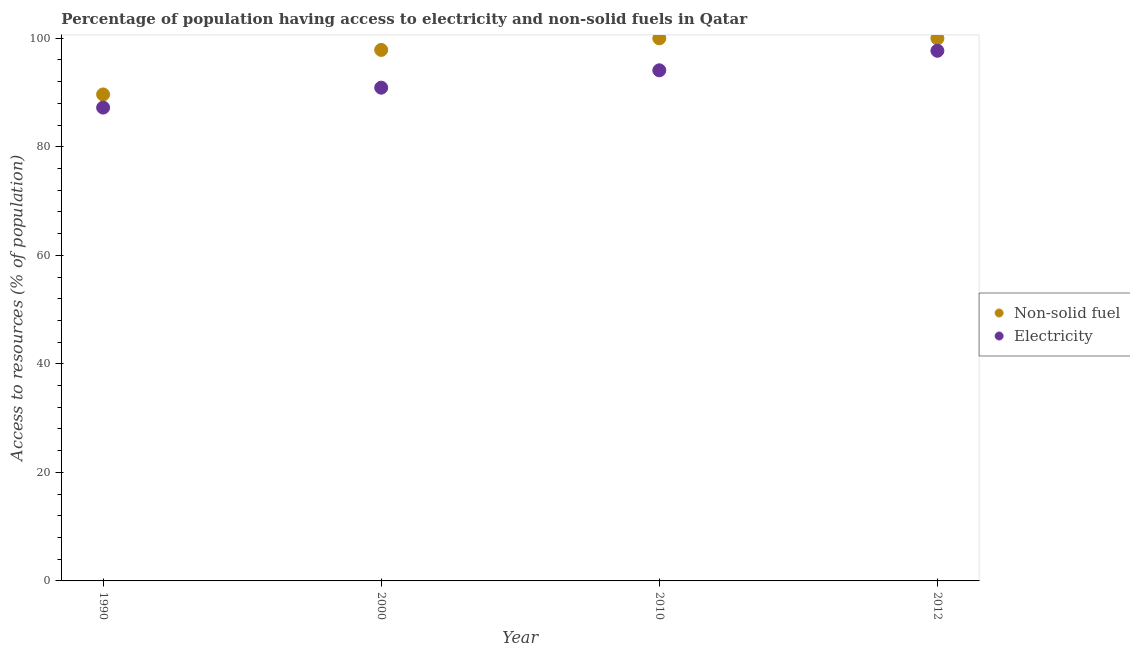What is the percentage of population having access to electricity in 1990?
Offer a terse response. 87.23. Across all years, what is the maximum percentage of population having access to non-solid fuel?
Provide a short and direct response. 99.99. Across all years, what is the minimum percentage of population having access to non-solid fuel?
Provide a short and direct response. 89.65. What is the total percentage of population having access to non-solid fuel in the graph?
Ensure brevity in your answer.  387.49. What is the difference between the percentage of population having access to non-solid fuel in 1990 and that in 2012?
Your response must be concise. -10.34. What is the difference between the percentage of population having access to non-solid fuel in 2012 and the percentage of population having access to electricity in 1990?
Provide a succinct answer. 12.76. What is the average percentage of population having access to electricity per year?
Provide a short and direct response. 92.48. In the year 2012, what is the difference between the percentage of population having access to electricity and percentage of population having access to non-solid fuel?
Make the answer very short. -2.29. In how many years, is the percentage of population having access to non-solid fuel greater than 64 %?
Offer a terse response. 4. What is the ratio of the percentage of population having access to non-solid fuel in 2010 to that in 2012?
Your response must be concise. 1. What is the difference between the highest and the lowest percentage of population having access to electricity?
Provide a short and direct response. 10.47. Is the sum of the percentage of population having access to non-solid fuel in 2000 and 2010 greater than the maximum percentage of population having access to electricity across all years?
Give a very brief answer. Yes. Does the percentage of population having access to electricity monotonically increase over the years?
Give a very brief answer. Yes. Is the percentage of population having access to electricity strictly less than the percentage of population having access to non-solid fuel over the years?
Ensure brevity in your answer.  Yes. How many dotlines are there?
Offer a terse response. 2. What is the difference between two consecutive major ticks on the Y-axis?
Your response must be concise. 20. Where does the legend appear in the graph?
Offer a very short reply. Center right. What is the title of the graph?
Ensure brevity in your answer.  Percentage of population having access to electricity and non-solid fuels in Qatar. What is the label or title of the Y-axis?
Provide a succinct answer. Access to resources (% of population). What is the Access to resources (% of population) in Non-solid fuel in 1990?
Your response must be concise. 89.65. What is the Access to resources (% of population) of Electricity in 1990?
Your answer should be very brief. 87.23. What is the Access to resources (% of population) in Non-solid fuel in 2000?
Make the answer very short. 97.86. What is the Access to resources (% of population) of Electricity in 2000?
Your response must be concise. 90.9. What is the Access to resources (% of population) of Non-solid fuel in 2010?
Provide a succinct answer. 99.99. What is the Access to resources (% of population) in Electricity in 2010?
Offer a terse response. 94.1. What is the Access to resources (% of population) in Non-solid fuel in 2012?
Your answer should be very brief. 99.99. What is the Access to resources (% of population) of Electricity in 2012?
Keep it short and to the point. 97.7. Across all years, what is the maximum Access to resources (% of population) in Non-solid fuel?
Offer a very short reply. 99.99. Across all years, what is the maximum Access to resources (% of population) in Electricity?
Provide a short and direct response. 97.7. Across all years, what is the minimum Access to resources (% of population) in Non-solid fuel?
Make the answer very short. 89.65. Across all years, what is the minimum Access to resources (% of population) in Electricity?
Ensure brevity in your answer.  87.23. What is the total Access to resources (% of population) in Non-solid fuel in the graph?
Provide a succinct answer. 387.49. What is the total Access to resources (% of population) in Electricity in the graph?
Give a very brief answer. 369.92. What is the difference between the Access to resources (% of population) in Non-solid fuel in 1990 and that in 2000?
Make the answer very short. -8.21. What is the difference between the Access to resources (% of population) in Electricity in 1990 and that in 2000?
Keep it short and to the point. -3.67. What is the difference between the Access to resources (% of population) of Non-solid fuel in 1990 and that in 2010?
Ensure brevity in your answer.  -10.34. What is the difference between the Access to resources (% of population) in Electricity in 1990 and that in 2010?
Ensure brevity in your answer.  -6.87. What is the difference between the Access to resources (% of population) in Non-solid fuel in 1990 and that in 2012?
Give a very brief answer. -10.34. What is the difference between the Access to resources (% of population) in Electricity in 1990 and that in 2012?
Ensure brevity in your answer.  -10.47. What is the difference between the Access to resources (% of population) in Non-solid fuel in 2000 and that in 2010?
Ensure brevity in your answer.  -2.13. What is the difference between the Access to resources (% of population) in Electricity in 2000 and that in 2010?
Provide a succinct answer. -3.2. What is the difference between the Access to resources (% of population) of Non-solid fuel in 2000 and that in 2012?
Provide a succinct answer. -2.13. What is the difference between the Access to resources (% of population) of Electricity in 2000 and that in 2012?
Keep it short and to the point. -6.8. What is the difference between the Access to resources (% of population) of Non-solid fuel in 2010 and that in 2012?
Your response must be concise. 0. What is the difference between the Access to resources (% of population) of Electricity in 2010 and that in 2012?
Make the answer very short. -3.6. What is the difference between the Access to resources (% of population) of Non-solid fuel in 1990 and the Access to resources (% of population) of Electricity in 2000?
Keep it short and to the point. -1.25. What is the difference between the Access to resources (% of population) in Non-solid fuel in 1990 and the Access to resources (% of population) in Electricity in 2010?
Ensure brevity in your answer.  -4.45. What is the difference between the Access to resources (% of population) in Non-solid fuel in 1990 and the Access to resources (% of population) in Electricity in 2012?
Your answer should be very brief. -8.05. What is the difference between the Access to resources (% of population) in Non-solid fuel in 2000 and the Access to resources (% of population) in Electricity in 2010?
Offer a very short reply. 3.76. What is the difference between the Access to resources (% of population) in Non-solid fuel in 2000 and the Access to resources (% of population) in Electricity in 2012?
Your response must be concise. 0.16. What is the difference between the Access to resources (% of population) in Non-solid fuel in 2010 and the Access to resources (% of population) in Electricity in 2012?
Offer a terse response. 2.29. What is the average Access to resources (% of population) of Non-solid fuel per year?
Your answer should be very brief. 96.87. What is the average Access to resources (% of population) in Electricity per year?
Your answer should be very brief. 92.48. In the year 1990, what is the difference between the Access to resources (% of population) in Non-solid fuel and Access to resources (% of population) in Electricity?
Your answer should be compact. 2.42. In the year 2000, what is the difference between the Access to resources (% of population) of Non-solid fuel and Access to resources (% of population) of Electricity?
Your response must be concise. 6.96. In the year 2010, what is the difference between the Access to resources (% of population) of Non-solid fuel and Access to resources (% of population) of Electricity?
Offer a terse response. 5.89. In the year 2012, what is the difference between the Access to resources (% of population) of Non-solid fuel and Access to resources (% of population) of Electricity?
Offer a terse response. 2.29. What is the ratio of the Access to resources (% of population) in Non-solid fuel in 1990 to that in 2000?
Your answer should be compact. 0.92. What is the ratio of the Access to resources (% of population) of Electricity in 1990 to that in 2000?
Give a very brief answer. 0.96. What is the ratio of the Access to resources (% of population) of Non-solid fuel in 1990 to that in 2010?
Your answer should be very brief. 0.9. What is the ratio of the Access to resources (% of population) in Electricity in 1990 to that in 2010?
Offer a terse response. 0.93. What is the ratio of the Access to resources (% of population) in Non-solid fuel in 1990 to that in 2012?
Make the answer very short. 0.9. What is the ratio of the Access to resources (% of population) in Electricity in 1990 to that in 2012?
Give a very brief answer. 0.89. What is the ratio of the Access to resources (% of population) of Non-solid fuel in 2000 to that in 2010?
Ensure brevity in your answer.  0.98. What is the ratio of the Access to resources (% of population) in Non-solid fuel in 2000 to that in 2012?
Ensure brevity in your answer.  0.98. What is the ratio of the Access to resources (% of population) in Electricity in 2000 to that in 2012?
Make the answer very short. 0.93. What is the ratio of the Access to resources (% of population) in Non-solid fuel in 2010 to that in 2012?
Offer a terse response. 1. What is the ratio of the Access to resources (% of population) in Electricity in 2010 to that in 2012?
Your answer should be very brief. 0.96. What is the difference between the highest and the second highest Access to resources (% of population) in Electricity?
Provide a short and direct response. 3.6. What is the difference between the highest and the lowest Access to resources (% of population) in Non-solid fuel?
Offer a very short reply. 10.34. What is the difference between the highest and the lowest Access to resources (% of population) of Electricity?
Offer a very short reply. 10.47. 